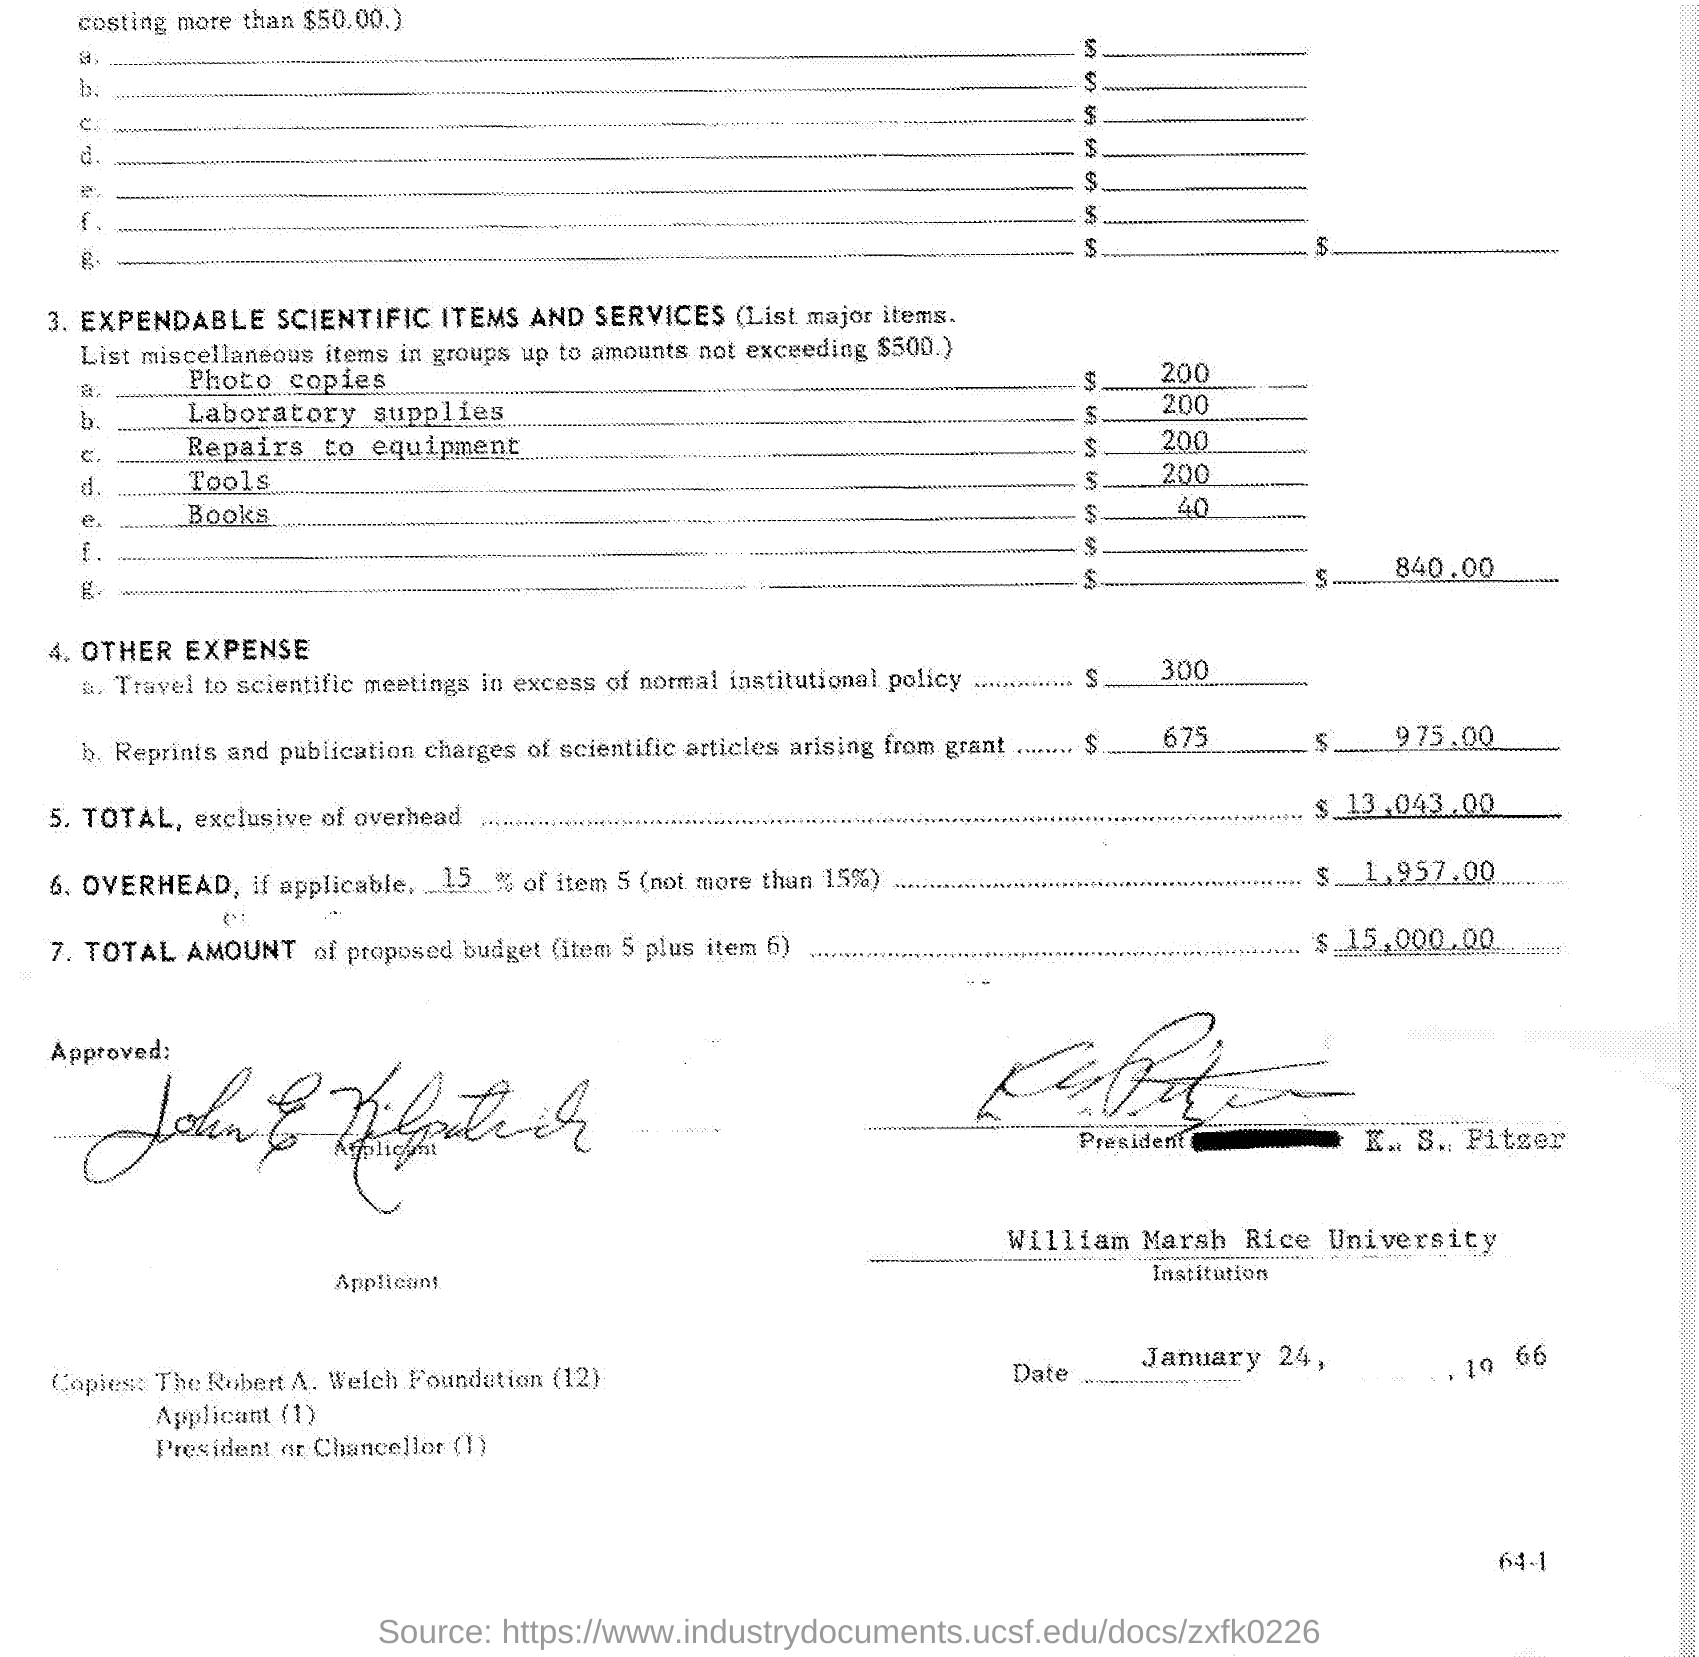Highlight a few significant elements in this photo. Forty dollars was charged for books. The cost for equipment repair is $200, The reprints and publication charges for scientific articles funded by the grant are $675. 